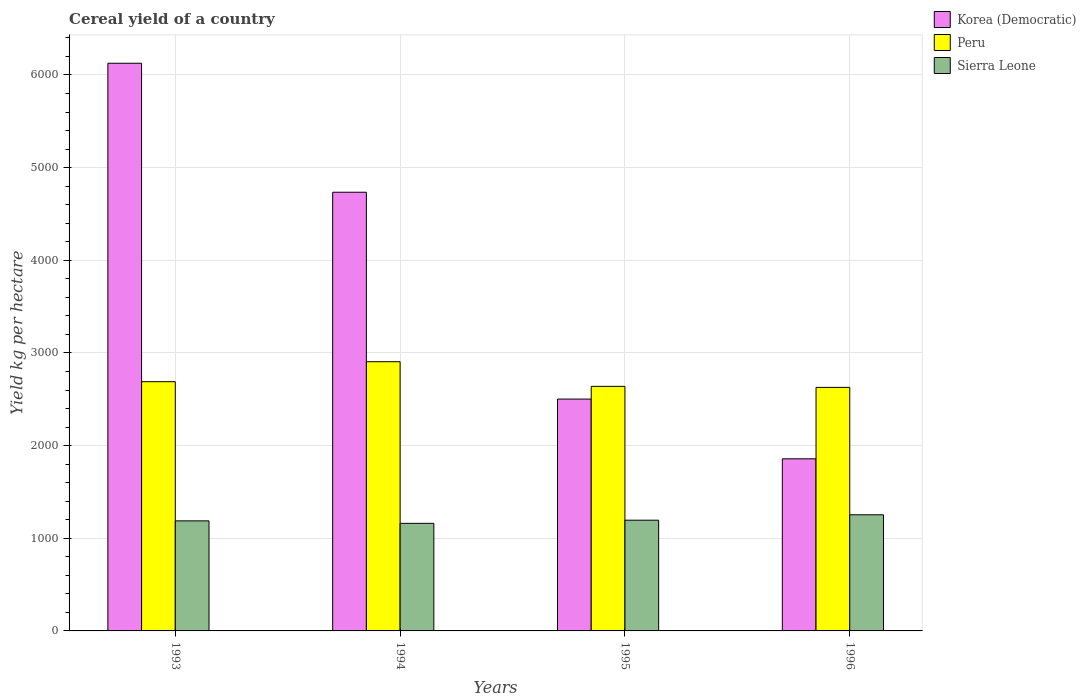How many different coloured bars are there?
Your response must be concise. 3. What is the total cereal yield in Sierra Leone in 1996?
Ensure brevity in your answer.  1253.32. Across all years, what is the maximum total cereal yield in Peru?
Keep it short and to the point. 2905.35. Across all years, what is the minimum total cereal yield in Peru?
Offer a very short reply. 2628.38. In which year was the total cereal yield in Korea (Democratic) maximum?
Make the answer very short. 1993. In which year was the total cereal yield in Peru minimum?
Give a very brief answer. 1996. What is the total total cereal yield in Peru in the graph?
Make the answer very short. 1.09e+04. What is the difference between the total cereal yield in Korea (Democratic) in 1993 and that in 1996?
Offer a terse response. 4268.77. What is the difference between the total cereal yield in Korea (Democratic) in 1996 and the total cereal yield in Peru in 1994?
Your response must be concise. -1047.77. What is the average total cereal yield in Sierra Leone per year?
Ensure brevity in your answer.  1199.28. In the year 1993, what is the difference between the total cereal yield in Sierra Leone and total cereal yield in Peru?
Give a very brief answer. -1501.96. What is the ratio of the total cereal yield in Sierra Leone in 1994 to that in 1996?
Offer a terse response. 0.93. Is the difference between the total cereal yield in Sierra Leone in 1993 and 1996 greater than the difference between the total cereal yield in Peru in 1993 and 1996?
Give a very brief answer. No. What is the difference between the highest and the second highest total cereal yield in Sierra Leone?
Offer a terse response. 58.36. What is the difference between the highest and the lowest total cereal yield in Korea (Democratic)?
Your answer should be compact. 4268.77. What does the 2nd bar from the left in 1995 represents?
Your response must be concise. Peru. What does the 3rd bar from the right in 1993 represents?
Provide a succinct answer. Korea (Democratic). How many years are there in the graph?
Ensure brevity in your answer.  4. What is the difference between two consecutive major ticks on the Y-axis?
Give a very brief answer. 1000. Does the graph contain any zero values?
Offer a terse response. No. Where does the legend appear in the graph?
Give a very brief answer. Top right. What is the title of the graph?
Your response must be concise. Cereal yield of a country. What is the label or title of the X-axis?
Ensure brevity in your answer.  Years. What is the label or title of the Y-axis?
Provide a succinct answer. Yield kg per hectare. What is the Yield kg per hectare of Korea (Democratic) in 1993?
Provide a succinct answer. 6126.36. What is the Yield kg per hectare of Peru in 1993?
Your response must be concise. 2689.75. What is the Yield kg per hectare of Sierra Leone in 1993?
Give a very brief answer. 1187.79. What is the Yield kg per hectare of Korea (Democratic) in 1994?
Give a very brief answer. 4734.38. What is the Yield kg per hectare in Peru in 1994?
Your answer should be compact. 2905.35. What is the Yield kg per hectare of Sierra Leone in 1994?
Your response must be concise. 1161.07. What is the Yield kg per hectare of Korea (Democratic) in 1995?
Offer a very short reply. 2502.13. What is the Yield kg per hectare in Peru in 1995?
Offer a very short reply. 2639.36. What is the Yield kg per hectare of Sierra Leone in 1995?
Your answer should be very brief. 1194.96. What is the Yield kg per hectare of Korea (Democratic) in 1996?
Your answer should be compact. 1857.58. What is the Yield kg per hectare in Peru in 1996?
Your answer should be very brief. 2628.38. What is the Yield kg per hectare of Sierra Leone in 1996?
Your response must be concise. 1253.32. Across all years, what is the maximum Yield kg per hectare of Korea (Democratic)?
Your answer should be very brief. 6126.36. Across all years, what is the maximum Yield kg per hectare in Peru?
Keep it short and to the point. 2905.35. Across all years, what is the maximum Yield kg per hectare in Sierra Leone?
Your answer should be very brief. 1253.32. Across all years, what is the minimum Yield kg per hectare in Korea (Democratic)?
Give a very brief answer. 1857.58. Across all years, what is the minimum Yield kg per hectare in Peru?
Provide a succinct answer. 2628.38. Across all years, what is the minimum Yield kg per hectare of Sierra Leone?
Offer a terse response. 1161.07. What is the total Yield kg per hectare of Korea (Democratic) in the graph?
Keep it short and to the point. 1.52e+04. What is the total Yield kg per hectare of Peru in the graph?
Ensure brevity in your answer.  1.09e+04. What is the total Yield kg per hectare in Sierra Leone in the graph?
Your response must be concise. 4797.13. What is the difference between the Yield kg per hectare of Korea (Democratic) in 1993 and that in 1994?
Provide a succinct answer. 1391.98. What is the difference between the Yield kg per hectare in Peru in 1993 and that in 1994?
Offer a very short reply. -215.6. What is the difference between the Yield kg per hectare of Sierra Leone in 1993 and that in 1994?
Give a very brief answer. 26.73. What is the difference between the Yield kg per hectare of Korea (Democratic) in 1993 and that in 1995?
Make the answer very short. 3624.23. What is the difference between the Yield kg per hectare of Peru in 1993 and that in 1995?
Your answer should be compact. 50.38. What is the difference between the Yield kg per hectare in Sierra Leone in 1993 and that in 1995?
Your answer should be compact. -7.17. What is the difference between the Yield kg per hectare of Korea (Democratic) in 1993 and that in 1996?
Keep it short and to the point. 4268.77. What is the difference between the Yield kg per hectare of Peru in 1993 and that in 1996?
Ensure brevity in your answer.  61.37. What is the difference between the Yield kg per hectare in Sierra Leone in 1993 and that in 1996?
Keep it short and to the point. -65.52. What is the difference between the Yield kg per hectare in Korea (Democratic) in 1994 and that in 1995?
Offer a very short reply. 2232.25. What is the difference between the Yield kg per hectare in Peru in 1994 and that in 1995?
Your answer should be compact. 265.99. What is the difference between the Yield kg per hectare in Sierra Leone in 1994 and that in 1995?
Make the answer very short. -33.89. What is the difference between the Yield kg per hectare in Korea (Democratic) in 1994 and that in 1996?
Provide a short and direct response. 2876.8. What is the difference between the Yield kg per hectare of Peru in 1994 and that in 1996?
Ensure brevity in your answer.  276.97. What is the difference between the Yield kg per hectare of Sierra Leone in 1994 and that in 1996?
Your answer should be compact. -92.25. What is the difference between the Yield kg per hectare in Korea (Democratic) in 1995 and that in 1996?
Make the answer very short. 644.55. What is the difference between the Yield kg per hectare in Peru in 1995 and that in 1996?
Your answer should be compact. 10.98. What is the difference between the Yield kg per hectare in Sierra Leone in 1995 and that in 1996?
Keep it short and to the point. -58.36. What is the difference between the Yield kg per hectare in Korea (Democratic) in 1993 and the Yield kg per hectare in Peru in 1994?
Offer a very short reply. 3221.01. What is the difference between the Yield kg per hectare in Korea (Democratic) in 1993 and the Yield kg per hectare in Sierra Leone in 1994?
Your answer should be very brief. 4965.29. What is the difference between the Yield kg per hectare of Peru in 1993 and the Yield kg per hectare of Sierra Leone in 1994?
Give a very brief answer. 1528.68. What is the difference between the Yield kg per hectare in Korea (Democratic) in 1993 and the Yield kg per hectare in Peru in 1995?
Your response must be concise. 3486.99. What is the difference between the Yield kg per hectare in Korea (Democratic) in 1993 and the Yield kg per hectare in Sierra Leone in 1995?
Ensure brevity in your answer.  4931.4. What is the difference between the Yield kg per hectare of Peru in 1993 and the Yield kg per hectare of Sierra Leone in 1995?
Provide a short and direct response. 1494.79. What is the difference between the Yield kg per hectare in Korea (Democratic) in 1993 and the Yield kg per hectare in Peru in 1996?
Give a very brief answer. 3497.98. What is the difference between the Yield kg per hectare of Korea (Democratic) in 1993 and the Yield kg per hectare of Sierra Leone in 1996?
Give a very brief answer. 4873.04. What is the difference between the Yield kg per hectare of Peru in 1993 and the Yield kg per hectare of Sierra Leone in 1996?
Keep it short and to the point. 1436.43. What is the difference between the Yield kg per hectare in Korea (Democratic) in 1994 and the Yield kg per hectare in Peru in 1995?
Keep it short and to the point. 2095.02. What is the difference between the Yield kg per hectare of Korea (Democratic) in 1994 and the Yield kg per hectare of Sierra Leone in 1995?
Keep it short and to the point. 3539.42. What is the difference between the Yield kg per hectare in Peru in 1994 and the Yield kg per hectare in Sierra Leone in 1995?
Make the answer very short. 1710.39. What is the difference between the Yield kg per hectare in Korea (Democratic) in 1994 and the Yield kg per hectare in Peru in 1996?
Offer a very short reply. 2106. What is the difference between the Yield kg per hectare of Korea (Democratic) in 1994 and the Yield kg per hectare of Sierra Leone in 1996?
Give a very brief answer. 3481.06. What is the difference between the Yield kg per hectare in Peru in 1994 and the Yield kg per hectare in Sierra Leone in 1996?
Offer a terse response. 1652.04. What is the difference between the Yield kg per hectare of Korea (Democratic) in 1995 and the Yield kg per hectare of Peru in 1996?
Provide a short and direct response. -126.25. What is the difference between the Yield kg per hectare in Korea (Democratic) in 1995 and the Yield kg per hectare in Sierra Leone in 1996?
Ensure brevity in your answer.  1248.81. What is the difference between the Yield kg per hectare in Peru in 1995 and the Yield kg per hectare in Sierra Leone in 1996?
Your answer should be very brief. 1386.05. What is the average Yield kg per hectare of Korea (Democratic) per year?
Give a very brief answer. 3805.11. What is the average Yield kg per hectare of Peru per year?
Offer a terse response. 2715.71. What is the average Yield kg per hectare in Sierra Leone per year?
Offer a terse response. 1199.28. In the year 1993, what is the difference between the Yield kg per hectare in Korea (Democratic) and Yield kg per hectare in Peru?
Make the answer very short. 3436.61. In the year 1993, what is the difference between the Yield kg per hectare in Korea (Democratic) and Yield kg per hectare in Sierra Leone?
Give a very brief answer. 4938.56. In the year 1993, what is the difference between the Yield kg per hectare in Peru and Yield kg per hectare in Sierra Leone?
Give a very brief answer. 1501.96. In the year 1994, what is the difference between the Yield kg per hectare in Korea (Democratic) and Yield kg per hectare in Peru?
Offer a terse response. 1829.03. In the year 1994, what is the difference between the Yield kg per hectare of Korea (Democratic) and Yield kg per hectare of Sierra Leone?
Offer a terse response. 3573.31. In the year 1994, what is the difference between the Yield kg per hectare of Peru and Yield kg per hectare of Sierra Leone?
Your answer should be compact. 1744.29. In the year 1995, what is the difference between the Yield kg per hectare of Korea (Democratic) and Yield kg per hectare of Peru?
Give a very brief answer. -137.23. In the year 1995, what is the difference between the Yield kg per hectare in Korea (Democratic) and Yield kg per hectare in Sierra Leone?
Your answer should be compact. 1307.17. In the year 1995, what is the difference between the Yield kg per hectare of Peru and Yield kg per hectare of Sierra Leone?
Your response must be concise. 1444.41. In the year 1996, what is the difference between the Yield kg per hectare in Korea (Democratic) and Yield kg per hectare in Peru?
Offer a very short reply. -770.8. In the year 1996, what is the difference between the Yield kg per hectare of Korea (Democratic) and Yield kg per hectare of Sierra Leone?
Your response must be concise. 604.27. In the year 1996, what is the difference between the Yield kg per hectare in Peru and Yield kg per hectare in Sierra Leone?
Give a very brief answer. 1375.06. What is the ratio of the Yield kg per hectare in Korea (Democratic) in 1993 to that in 1994?
Provide a succinct answer. 1.29. What is the ratio of the Yield kg per hectare of Peru in 1993 to that in 1994?
Keep it short and to the point. 0.93. What is the ratio of the Yield kg per hectare of Sierra Leone in 1993 to that in 1994?
Make the answer very short. 1.02. What is the ratio of the Yield kg per hectare of Korea (Democratic) in 1993 to that in 1995?
Your answer should be compact. 2.45. What is the ratio of the Yield kg per hectare in Peru in 1993 to that in 1995?
Your response must be concise. 1.02. What is the ratio of the Yield kg per hectare of Korea (Democratic) in 1993 to that in 1996?
Keep it short and to the point. 3.3. What is the ratio of the Yield kg per hectare of Peru in 1993 to that in 1996?
Your answer should be compact. 1.02. What is the ratio of the Yield kg per hectare in Sierra Leone in 1993 to that in 1996?
Your answer should be compact. 0.95. What is the ratio of the Yield kg per hectare in Korea (Democratic) in 1994 to that in 1995?
Your answer should be compact. 1.89. What is the ratio of the Yield kg per hectare of Peru in 1994 to that in 1995?
Ensure brevity in your answer.  1.1. What is the ratio of the Yield kg per hectare of Sierra Leone in 1994 to that in 1995?
Keep it short and to the point. 0.97. What is the ratio of the Yield kg per hectare in Korea (Democratic) in 1994 to that in 1996?
Provide a short and direct response. 2.55. What is the ratio of the Yield kg per hectare of Peru in 1994 to that in 1996?
Your answer should be compact. 1.11. What is the ratio of the Yield kg per hectare in Sierra Leone in 1994 to that in 1996?
Offer a terse response. 0.93. What is the ratio of the Yield kg per hectare of Korea (Democratic) in 1995 to that in 1996?
Your response must be concise. 1.35. What is the ratio of the Yield kg per hectare in Peru in 1995 to that in 1996?
Keep it short and to the point. 1. What is the ratio of the Yield kg per hectare in Sierra Leone in 1995 to that in 1996?
Make the answer very short. 0.95. What is the difference between the highest and the second highest Yield kg per hectare of Korea (Democratic)?
Keep it short and to the point. 1391.98. What is the difference between the highest and the second highest Yield kg per hectare of Peru?
Your answer should be very brief. 215.6. What is the difference between the highest and the second highest Yield kg per hectare in Sierra Leone?
Offer a very short reply. 58.36. What is the difference between the highest and the lowest Yield kg per hectare of Korea (Democratic)?
Offer a very short reply. 4268.77. What is the difference between the highest and the lowest Yield kg per hectare of Peru?
Offer a very short reply. 276.97. What is the difference between the highest and the lowest Yield kg per hectare in Sierra Leone?
Offer a terse response. 92.25. 